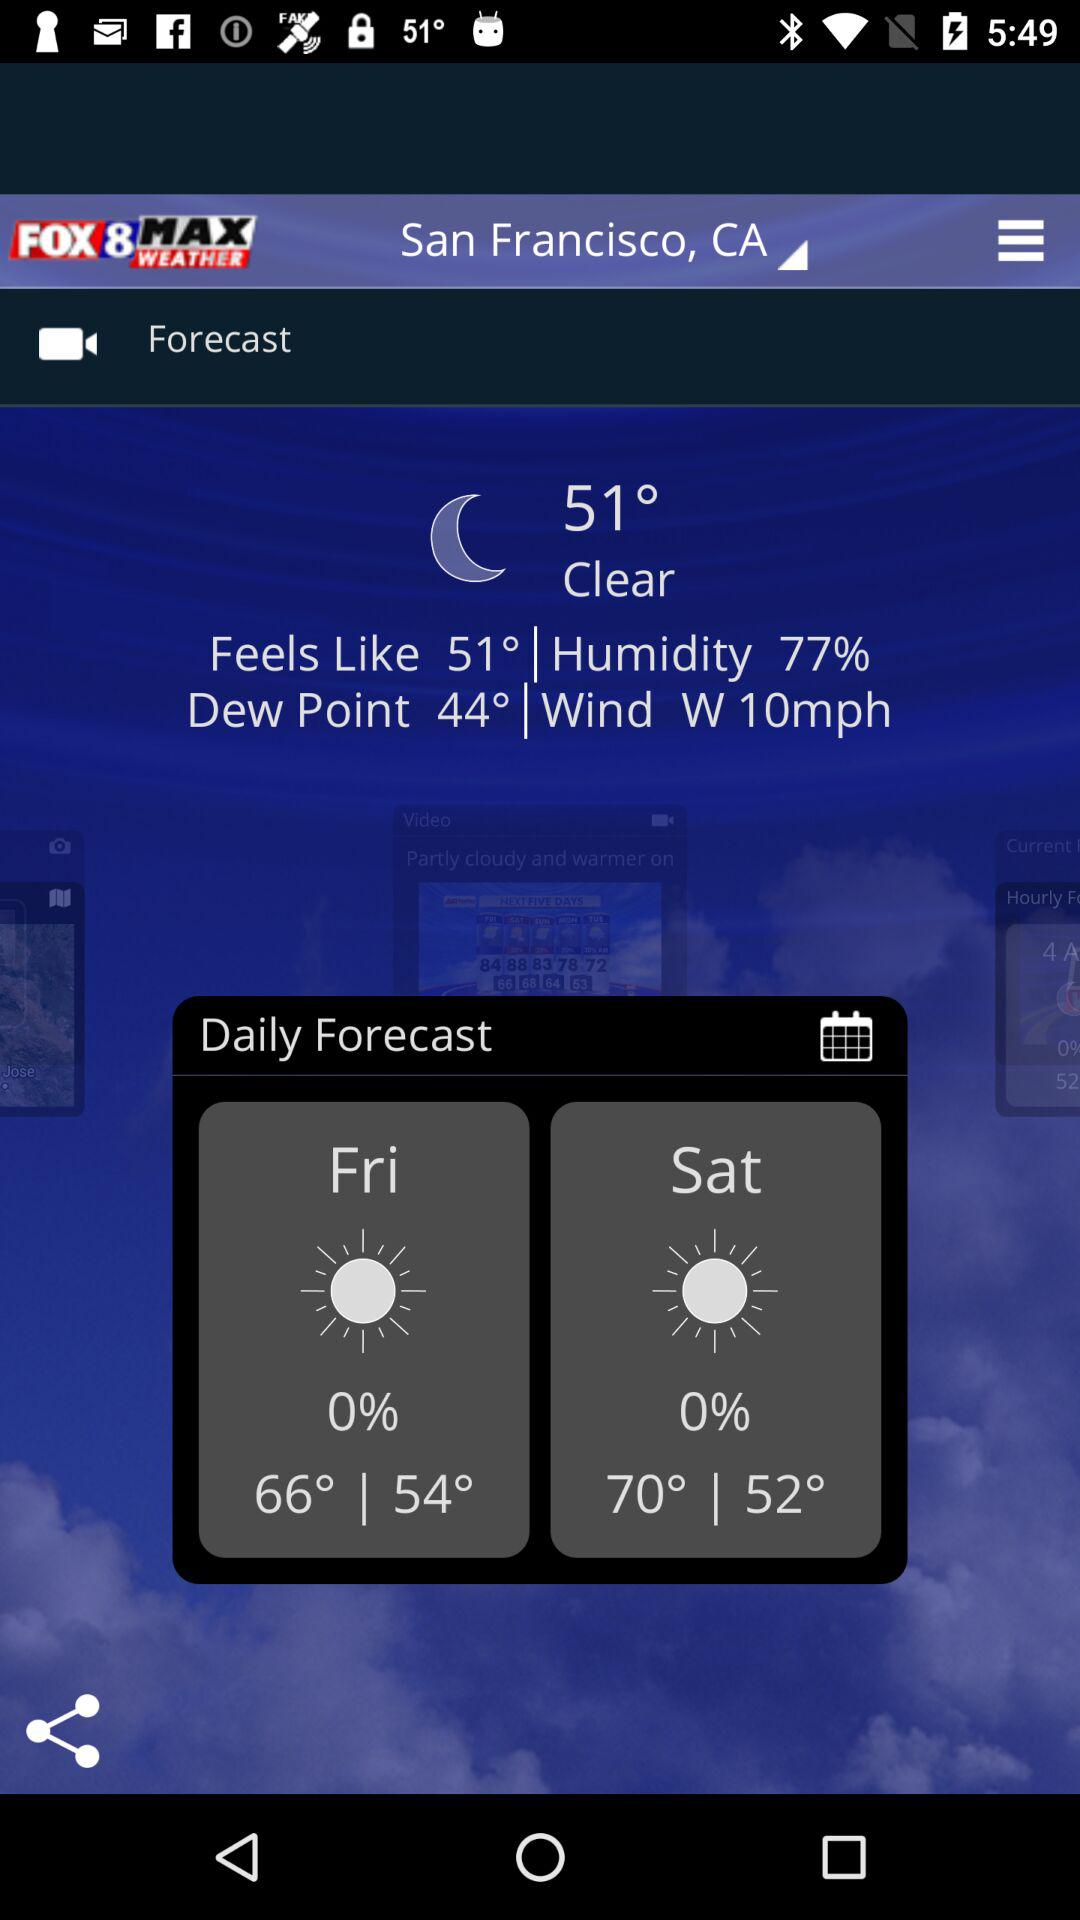How many degrees warmer is the high temperature for Saturday than the high temperature for Friday?
Answer the question using a single word or phrase. 4 